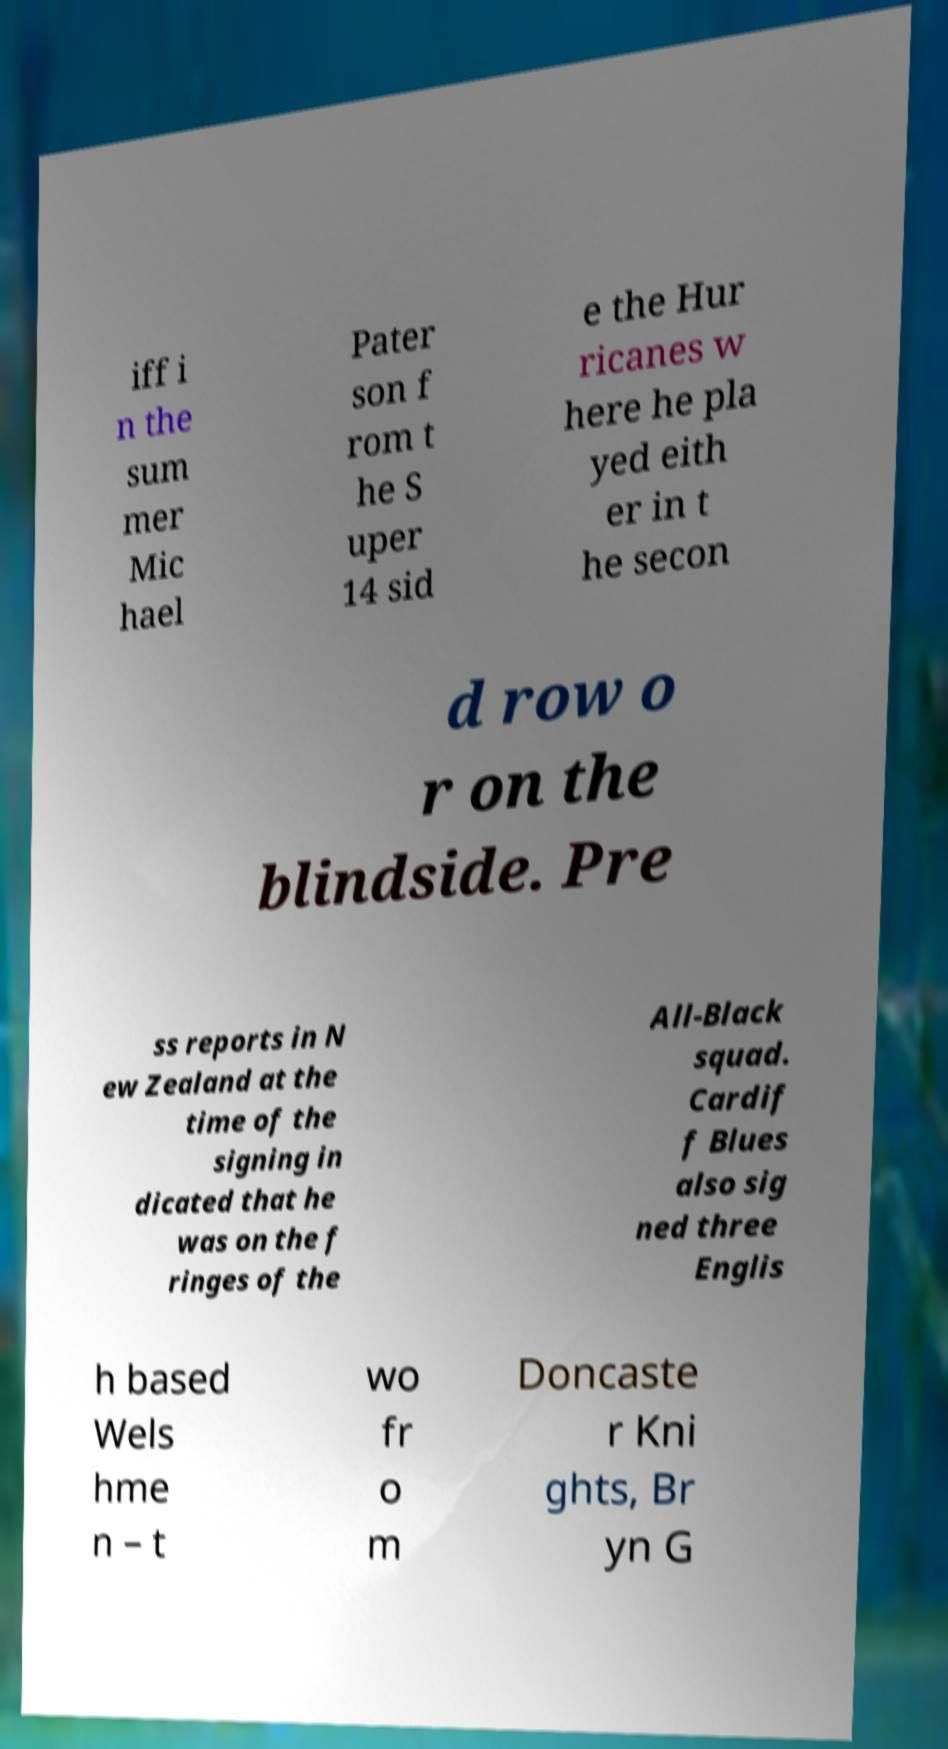I need the written content from this picture converted into text. Can you do that? iff i n the sum mer Mic hael Pater son f rom t he S uper 14 sid e the Hur ricanes w here he pla yed eith er in t he secon d row o r on the blindside. Pre ss reports in N ew Zealand at the time of the signing in dicated that he was on the f ringes of the All-Black squad. Cardif f Blues also sig ned three Englis h based Wels hme n – t wo fr o m Doncaste r Kni ghts, Br yn G 